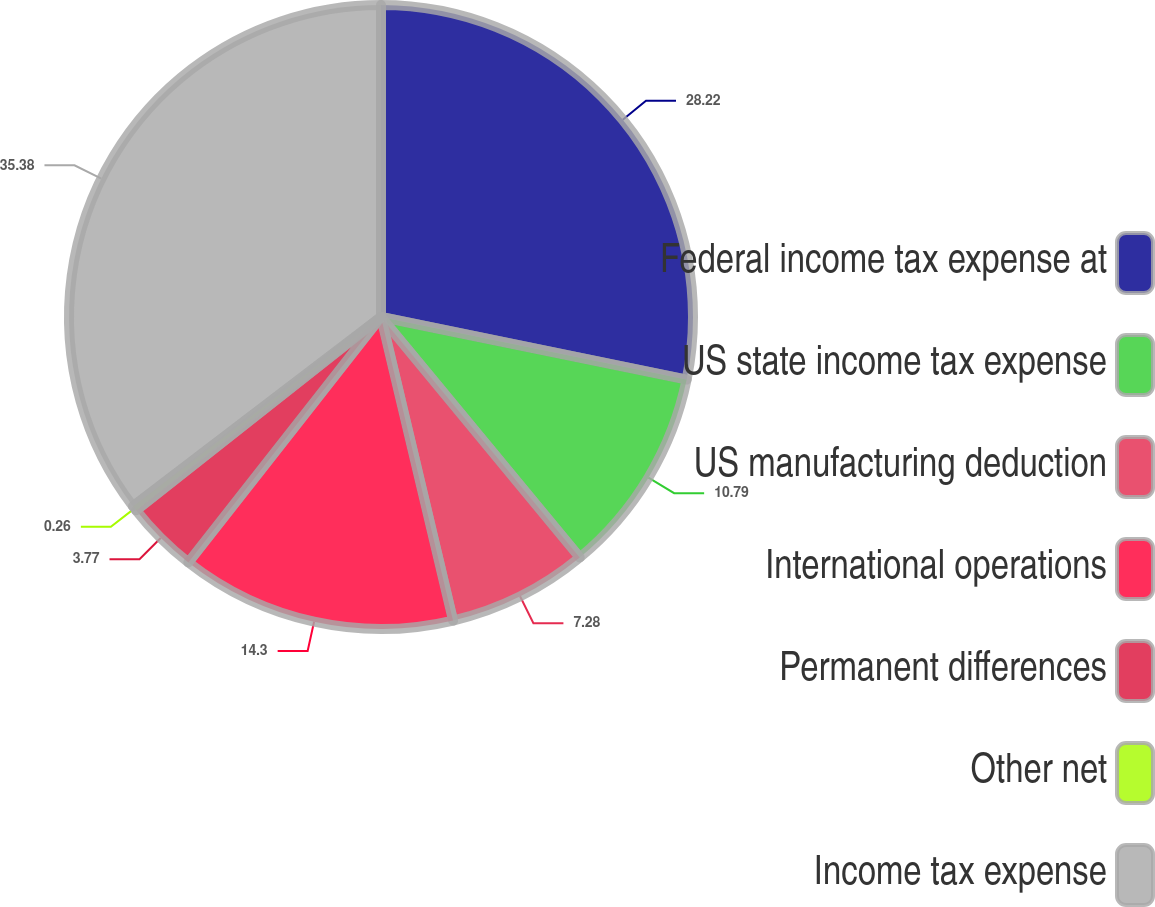<chart> <loc_0><loc_0><loc_500><loc_500><pie_chart><fcel>Federal income tax expense at<fcel>US state income tax expense<fcel>US manufacturing deduction<fcel>International operations<fcel>Permanent differences<fcel>Other net<fcel>Income tax expense<nl><fcel>28.21%<fcel>10.79%<fcel>7.28%<fcel>14.3%<fcel>3.77%<fcel>0.26%<fcel>35.37%<nl></chart> 